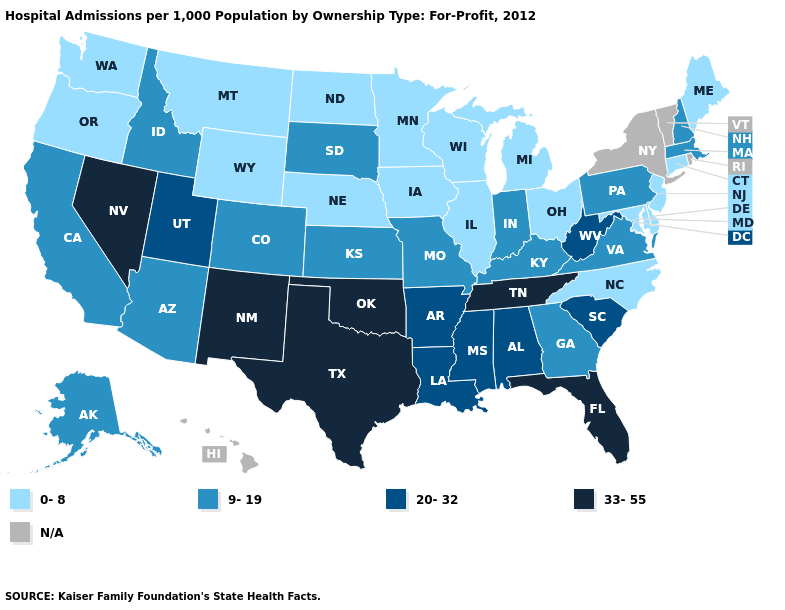Name the states that have a value in the range 9-19?
Write a very short answer. Alaska, Arizona, California, Colorado, Georgia, Idaho, Indiana, Kansas, Kentucky, Massachusetts, Missouri, New Hampshire, Pennsylvania, South Dakota, Virginia. Which states have the lowest value in the USA?
Be succinct. Connecticut, Delaware, Illinois, Iowa, Maine, Maryland, Michigan, Minnesota, Montana, Nebraska, New Jersey, North Carolina, North Dakota, Ohio, Oregon, Washington, Wisconsin, Wyoming. Among the states that border Florida , does Georgia have the highest value?
Be succinct. No. Does Maine have the highest value in the Northeast?
Answer briefly. No. Name the states that have a value in the range 0-8?
Short answer required. Connecticut, Delaware, Illinois, Iowa, Maine, Maryland, Michigan, Minnesota, Montana, Nebraska, New Jersey, North Carolina, North Dakota, Ohio, Oregon, Washington, Wisconsin, Wyoming. Does Delaware have the lowest value in the South?
Be succinct. Yes. What is the value of Minnesota?
Answer briefly. 0-8. Name the states that have a value in the range 9-19?
Write a very short answer. Alaska, Arizona, California, Colorado, Georgia, Idaho, Indiana, Kansas, Kentucky, Massachusetts, Missouri, New Hampshire, Pennsylvania, South Dakota, Virginia. What is the value of Maryland?
Answer briefly. 0-8. Does Tennessee have the highest value in the USA?
Be succinct. Yes. Does the map have missing data?
Short answer required. Yes. What is the value of Georgia?
Answer briefly. 9-19. What is the lowest value in the South?
Be succinct. 0-8. Name the states that have a value in the range N/A?
Keep it brief. Hawaii, New York, Rhode Island, Vermont. 